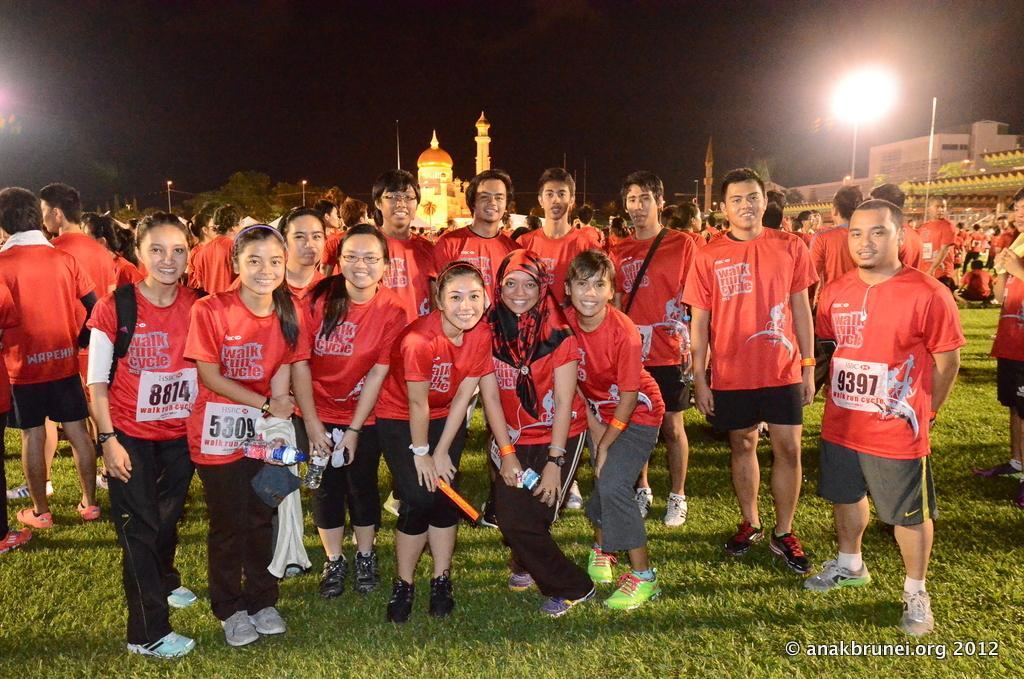Describe this image in one or two sentences. In this picture we can see a group of people standing on the grass. We can see some people are holding objects in their hands. There are a few poles, lights and buildings in the background. We can see some objects on the right side. There is the dark view visible on top of the picture. 